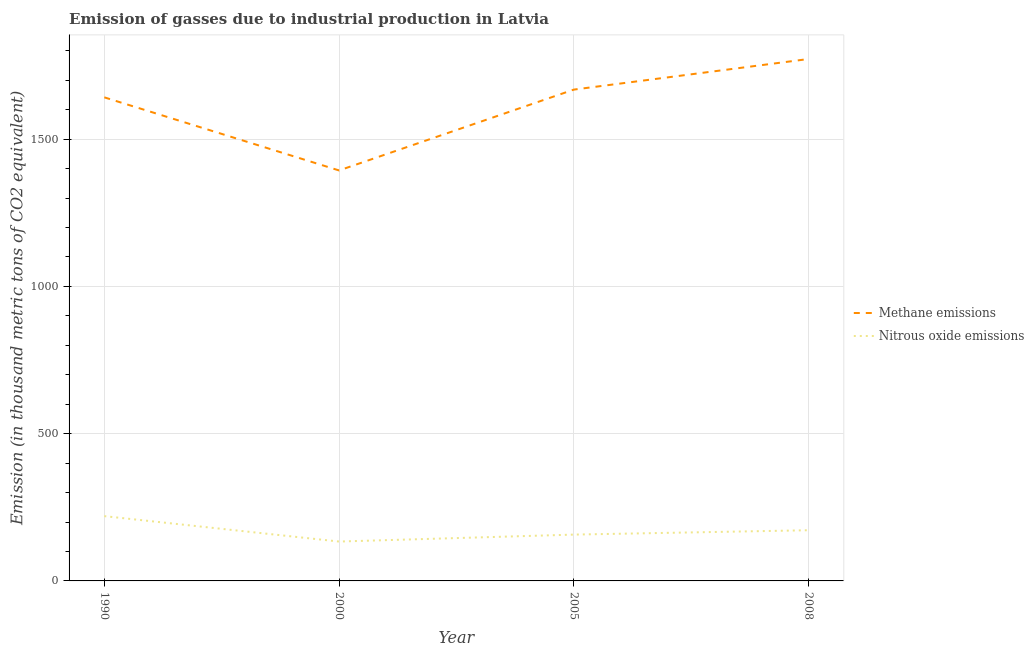Is the number of lines equal to the number of legend labels?
Your answer should be very brief. Yes. What is the amount of nitrous oxide emissions in 2000?
Make the answer very short. 133.7. Across all years, what is the maximum amount of nitrous oxide emissions?
Your answer should be very brief. 220. Across all years, what is the minimum amount of methane emissions?
Provide a succinct answer. 1393.8. In which year was the amount of methane emissions maximum?
Provide a short and direct response. 2008. What is the total amount of nitrous oxide emissions in the graph?
Offer a terse response. 683.1. What is the difference between the amount of nitrous oxide emissions in 1990 and that in 2000?
Your answer should be very brief. 86.3. What is the difference between the amount of nitrous oxide emissions in 2005 and the amount of methane emissions in 1990?
Your answer should be compact. -1484.7. What is the average amount of nitrous oxide emissions per year?
Offer a very short reply. 170.78. In the year 2008, what is the difference between the amount of nitrous oxide emissions and amount of methane emissions?
Keep it short and to the point. -1600.1. In how many years, is the amount of methane emissions greater than 600 thousand metric tons?
Give a very brief answer. 4. What is the ratio of the amount of nitrous oxide emissions in 2000 to that in 2005?
Ensure brevity in your answer.  0.85. Is the amount of nitrous oxide emissions in 1990 less than that in 2005?
Offer a very short reply. No. What is the difference between the highest and the second highest amount of methane emissions?
Keep it short and to the point. 103.9. What is the difference between the highest and the lowest amount of nitrous oxide emissions?
Ensure brevity in your answer.  86.3. Is the sum of the amount of methane emissions in 2005 and 2008 greater than the maximum amount of nitrous oxide emissions across all years?
Make the answer very short. Yes. Is the amount of nitrous oxide emissions strictly greater than the amount of methane emissions over the years?
Your response must be concise. No. Is the amount of methane emissions strictly less than the amount of nitrous oxide emissions over the years?
Your response must be concise. No. How many lines are there?
Provide a short and direct response. 2. Are the values on the major ticks of Y-axis written in scientific E-notation?
Your answer should be compact. No. Where does the legend appear in the graph?
Provide a succinct answer. Center right. How many legend labels are there?
Make the answer very short. 2. What is the title of the graph?
Keep it short and to the point. Emission of gasses due to industrial production in Latvia. What is the label or title of the Y-axis?
Your answer should be compact. Emission (in thousand metric tons of CO2 equivalent). What is the Emission (in thousand metric tons of CO2 equivalent) in Methane emissions in 1990?
Provide a succinct answer. 1642. What is the Emission (in thousand metric tons of CO2 equivalent) of Nitrous oxide emissions in 1990?
Offer a terse response. 220. What is the Emission (in thousand metric tons of CO2 equivalent) of Methane emissions in 2000?
Your answer should be compact. 1393.8. What is the Emission (in thousand metric tons of CO2 equivalent) of Nitrous oxide emissions in 2000?
Give a very brief answer. 133.7. What is the Emission (in thousand metric tons of CO2 equivalent) of Methane emissions in 2005?
Keep it short and to the point. 1668.3. What is the Emission (in thousand metric tons of CO2 equivalent) of Nitrous oxide emissions in 2005?
Offer a terse response. 157.3. What is the Emission (in thousand metric tons of CO2 equivalent) in Methane emissions in 2008?
Ensure brevity in your answer.  1772.2. What is the Emission (in thousand metric tons of CO2 equivalent) of Nitrous oxide emissions in 2008?
Your response must be concise. 172.1. Across all years, what is the maximum Emission (in thousand metric tons of CO2 equivalent) in Methane emissions?
Provide a short and direct response. 1772.2. Across all years, what is the maximum Emission (in thousand metric tons of CO2 equivalent) in Nitrous oxide emissions?
Offer a very short reply. 220. Across all years, what is the minimum Emission (in thousand metric tons of CO2 equivalent) in Methane emissions?
Ensure brevity in your answer.  1393.8. Across all years, what is the minimum Emission (in thousand metric tons of CO2 equivalent) of Nitrous oxide emissions?
Provide a succinct answer. 133.7. What is the total Emission (in thousand metric tons of CO2 equivalent) of Methane emissions in the graph?
Your response must be concise. 6476.3. What is the total Emission (in thousand metric tons of CO2 equivalent) of Nitrous oxide emissions in the graph?
Ensure brevity in your answer.  683.1. What is the difference between the Emission (in thousand metric tons of CO2 equivalent) of Methane emissions in 1990 and that in 2000?
Provide a succinct answer. 248.2. What is the difference between the Emission (in thousand metric tons of CO2 equivalent) of Nitrous oxide emissions in 1990 and that in 2000?
Offer a terse response. 86.3. What is the difference between the Emission (in thousand metric tons of CO2 equivalent) of Methane emissions in 1990 and that in 2005?
Offer a very short reply. -26.3. What is the difference between the Emission (in thousand metric tons of CO2 equivalent) in Nitrous oxide emissions in 1990 and that in 2005?
Offer a terse response. 62.7. What is the difference between the Emission (in thousand metric tons of CO2 equivalent) in Methane emissions in 1990 and that in 2008?
Ensure brevity in your answer.  -130.2. What is the difference between the Emission (in thousand metric tons of CO2 equivalent) in Nitrous oxide emissions in 1990 and that in 2008?
Offer a terse response. 47.9. What is the difference between the Emission (in thousand metric tons of CO2 equivalent) in Methane emissions in 2000 and that in 2005?
Keep it short and to the point. -274.5. What is the difference between the Emission (in thousand metric tons of CO2 equivalent) of Nitrous oxide emissions in 2000 and that in 2005?
Offer a very short reply. -23.6. What is the difference between the Emission (in thousand metric tons of CO2 equivalent) of Methane emissions in 2000 and that in 2008?
Make the answer very short. -378.4. What is the difference between the Emission (in thousand metric tons of CO2 equivalent) of Nitrous oxide emissions in 2000 and that in 2008?
Your answer should be very brief. -38.4. What is the difference between the Emission (in thousand metric tons of CO2 equivalent) of Methane emissions in 2005 and that in 2008?
Offer a very short reply. -103.9. What is the difference between the Emission (in thousand metric tons of CO2 equivalent) in Nitrous oxide emissions in 2005 and that in 2008?
Provide a short and direct response. -14.8. What is the difference between the Emission (in thousand metric tons of CO2 equivalent) in Methane emissions in 1990 and the Emission (in thousand metric tons of CO2 equivalent) in Nitrous oxide emissions in 2000?
Keep it short and to the point. 1508.3. What is the difference between the Emission (in thousand metric tons of CO2 equivalent) in Methane emissions in 1990 and the Emission (in thousand metric tons of CO2 equivalent) in Nitrous oxide emissions in 2005?
Provide a succinct answer. 1484.7. What is the difference between the Emission (in thousand metric tons of CO2 equivalent) of Methane emissions in 1990 and the Emission (in thousand metric tons of CO2 equivalent) of Nitrous oxide emissions in 2008?
Offer a terse response. 1469.9. What is the difference between the Emission (in thousand metric tons of CO2 equivalent) in Methane emissions in 2000 and the Emission (in thousand metric tons of CO2 equivalent) in Nitrous oxide emissions in 2005?
Give a very brief answer. 1236.5. What is the difference between the Emission (in thousand metric tons of CO2 equivalent) in Methane emissions in 2000 and the Emission (in thousand metric tons of CO2 equivalent) in Nitrous oxide emissions in 2008?
Offer a terse response. 1221.7. What is the difference between the Emission (in thousand metric tons of CO2 equivalent) in Methane emissions in 2005 and the Emission (in thousand metric tons of CO2 equivalent) in Nitrous oxide emissions in 2008?
Offer a terse response. 1496.2. What is the average Emission (in thousand metric tons of CO2 equivalent) in Methane emissions per year?
Your response must be concise. 1619.08. What is the average Emission (in thousand metric tons of CO2 equivalent) in Nitrous oxide emissions per year?
Make the answer very short. 170.78. In the year 1990, what is the difference between the Emission (in thousand metric tons of CO2 equivalent) of Methane emissions and Emission (in thousand metric tons of CO2 equivalent) of Nitrous oxide emissions?
Provide a succinct answer. 1422. In the year 2000, what is the difference between the Emission (in thousand metric tons of CO2 equivalent) of Methane emissions and Emission (in thousand metric tons of CO2 equivalent) of Nitrous oxide emissions?
Provide a short and direct response. 1260.1. In the year 2005, what is the difference between the Emission (in thousand metric tons of CO2 equivalent) in Methane emissions and Emission (in thousand metric tons of CO2 equivalent) in Nitrous oxide emissions?
Your response must be concise. 1511. In the year 2008, what is the difference between the Emission (in thousand metric tons of CO2 equivalent) of Methane emissions and Emission (in thousand metric tons of CO2 equivalent) of Nitrous oxide emissions?
Ensure brevity in your answer.  1600.1. What is the ratio of the Emission (in thousand metric tons of CO2 equivalent) of Methane emissions in 1990 to that in 2000?
Provide a short and direct response. 1.18. What is the ratio of the Emission (in thousand metric tons of CO2 equivalent) of Nitrous oxide emissions in 1990 to that in 2000?
Keep it short and to the point. 1.65. What is the ratio of the Emission (in thousand metric tons of CO2 equivalent) in Methane emissions in 1990 to that in 2005?
Provide a succinct answer. 0.98. What is the ratio of the Emission (in thousand metric tons of CO2 equivalent) of Nitrous oxide emissions in 1990 to that in 2005?
Your answer should be compact. 1.4. What is the ratio of the Emission (in thousand metric tons of CO2 equivalent) in Methane emissions in 1990 to that in 2008?
Provide a short and direct response. 0.93. What is the ratio of the Emission (in thousand metric tons of CO2 equivalent) in Nitrous oxide emissions in 1990 to that in 2008?
Your answer should be compact. 1.28. What is the ratio of the Emission (in thousand metric tons of CO2 equivalent) of Methane emissions in 2000 to that in 2005?
Ensure brevity in your answer.  0.84. What is the ratio of the Emission (in thousand metric tons of CO2 equivalent) of Nitrous oxide emissions in 2000 to that in 2005?
Offer a terse response. 0.85. What is the ratio of the Emission (in thousand metric tons of CO2 equivalent) of Methane emissions in 2000 to that in 2008?
Ensure brevity in your answer.  0.79. What is the ratio of the Emission (in thousand metric tons of CO2 equivalent) in Nitrous oxide emissions in 2000 to that in 2008?
Keep it short and to the point. 0.78. What is the ratio of the Emission (in thousand metric tons of CO2 equivalent) of Methane emissions in 2005 to that in 2008?
Provide a short and direct response. 0.94. What is the ratio of the Emission (in thousand metric tons of CO2 equivalent) of Nitrous oxide emissions in 2005 to that in 2008?
Ensure brevity in your answer.  0.91. What is the difference between the highest and the second highest Emission (in thousand metric tons of CO2 equivalent) of Methane emissions?
Make the answer very short. 103.9. What is the difference between the highest and the second highest Emission (in thousand metric tons of CO2 equivalent) in Nitrous oxide emissions?
Ensure brevity in your answer.  47.9. What is the difference between the highest and the lowest Emission (in thousand metric tons of CO2 equivalent) of Methane emissions?
Your answer should be compact. 378.4. What is the difference between the highest and the lowest Emission (in thousand metric tons of CO2 equivalent) in Nitrous oxide emissions?
Ensure brevity in your answer.  86.3. 